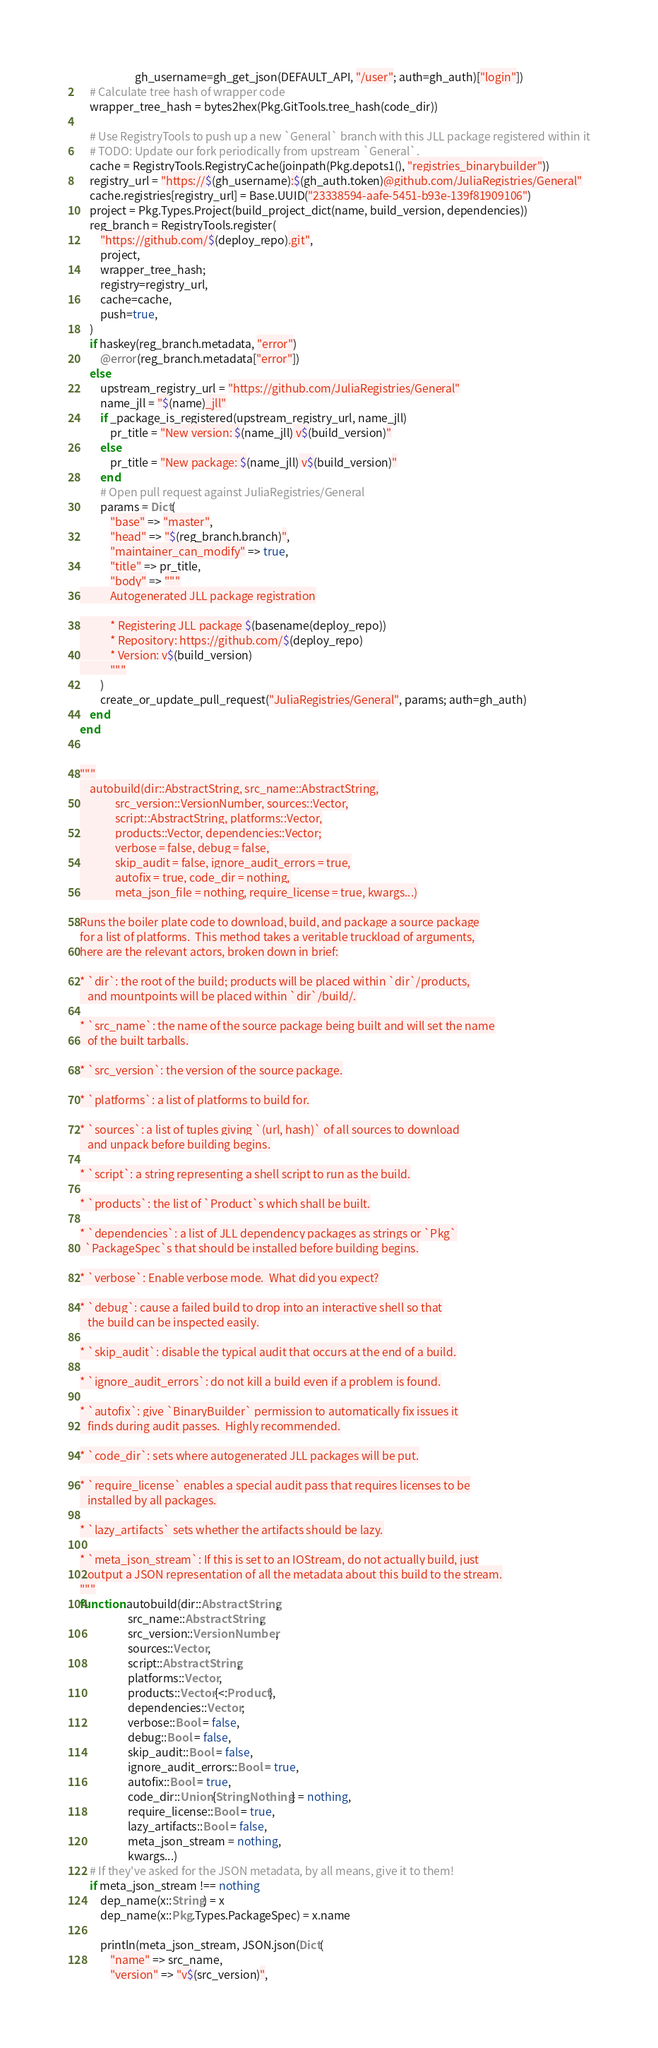Convert code to text. <code><loc_0><loc_0><loc_500><loc_500><_Julia_>                      gh_username=gh_get_json(DEFAULT_API, "/user"; auth=gh_auth)["login"])
    # Calculate tree hash of wrapper code
    wrapper_tree_hash = bytes2hex(Pkg.GitTools.tree_hash(code_dir))

    # Use RegistryTools to push up a new `General` branch with this JLL package registered within it
    # TODO: Update our fork periodically from upstream `General`.
    cache = RegistryTools.RegistryCache(joinpath(Pkg.depots1(), "registries_binarybuilder"))
    registry_url = "https://$(gh_username):$(gh_auth.token)@github.com/JuliaRegistries/General"
    cache.registries[registry_url] = Base.UUID("23338594-aafe-5451-b93e-139f81909106")
    project = Pkg.Types.Project(build_project_dict(name, build_version, dependencies))
    reg_branch = RegistryTools.register(
        "https://github.com/$(deploy_repo).git",
        project,
        wrapper_tree_hash;
        registry=registry_url,
        cache=cache,
        push=true,
    )
    if haskey(reg_branch.metadata, "error")
        @error(reg_branch.metadata["error"])
    else
        upstream_registry_url = "https://github.com/JuliaRegistries/General"
        name_jll = "$(name)_jll"
        if _package_is_registered(upstream_registry_url, name_jll)
            pr_title = "New version: $(name_jll) v$(build_version)"
        else
            pr_title = "New package: $(name_jll) v$(build_version)"
        end
        # Open pull request against JuliaRegistries/General
        params = Dict(
            "base" => "master",
            "head" => "$(reg_branch.branch)",
            "maintainer_can_modify" => true,
            "title" => pr_title,
            "body" => """
            Autogenerated JLL package registration

            * Registering JLL package $(basename(deploy_repo))
            * Repository: https://github.com/$(deploy_repo)
            * Version: v$(build_version)
            """
        )
        create_or_update_pull_request("JuliaRegistries/General", params; auth=gh_auth)
    end
end


"""
    autobuild(dir::AbstractString, src_name::AbstractString,
              src_version::VersionNumber, sources::Vector,
              script::AbstractString, platforms::Vector,
              products::Vector, dependencies::Vector;
              verbose = false, debug = false,
              skip_audit = false, ignore_audit_errors = true,
              autofix = true, code_dir = nothing,
              meta_json_file = nothing, require_license = true, kwargs...)

Runs the boiler plate code to download, build, and package a source package
for a list of platforms.  This method takes a veritable truckload of arguments,
here are the relevant actors, broken down in brief:

* `dir`: the root of the build; products will be placed within `dir`/products,
   and mountpoints will be placed within `dir`/build/.

* `src_name`: the name of the source package being built and will set the name
   of the built tarballs.

* `src_version`: the version of the source package.

* `platforms`: a list of platforms to build for.

* `sources`: a list of tuples giving `(url, hash)` of all sources to download
   and unpack before building begins.

* `script`: a string representing a shell script to run as the build.

* `products`: the list of `Product`s which shall be built.

* `dependencies`: a list of JLL dependency packages as strings or `Pkg`
  `PackageSpec`s that should be installed before building begins.

* `verbose`: Enable verbose mode.  What did you expect?

* `debug`: cause a failed build to drop into an interactive shell so that
   the build can be inspected easily.

* `skip_audit`: disable the typical audit that occurs at the end of a build.

* `ignore_audit_errors`: do not kill a build even if a problem is found.

* `autofix`: give `BinaryBuilder` permission to automatically fix issues it
   finds during audit passes.  Highly recommended.

* `code_dir`: sets where autogenerated JLL packages will be put.

* `require_license` enables a special audit pass that requires licenses to be
   installed by all packages.

* `lazy_artifacts` sets whether the artifacts should be lazy.

* `meta_json_stream`: If this is set to an IOStream, do not actually build, just
   output a JSON representation of all the metadata about this build to the stream.
"""
function autobuild(dir::AbstractString,
                   src_name::AbstractString,
                   src_version::VersionNumber,
                   sources::Vector,
                   script::AbstractString,
                   platforms::Vector,
                   products::Vector{<:Product},
                   dependencies::Vector;
                   verbose::Bool = false,
                   debug::Bool = false,
                   skip_audit::Bool = false,
                   ignore_audit_errors::Bool = true,
                   autofix::Bool = true,
                   code_dir::Union{String,Nothing} = nothing,
                   require_license::Bool = true,
                   lazy_artifacts::Bool = false,
                   meta_json_stream = nothing,
                   kwargs...)
    # If they've asked for the JSON metadata, by all means, give it to them!
    if meta_json_stream !== nothing
        dep_name(x::String) = x
        dep_name(x::Pkg.Types.PackageSpec) = x.name

        println(meta_json_stream, JSON.json(Dict(
            "name" => src_name,
            "version" => "v$(src_version)",</code> 